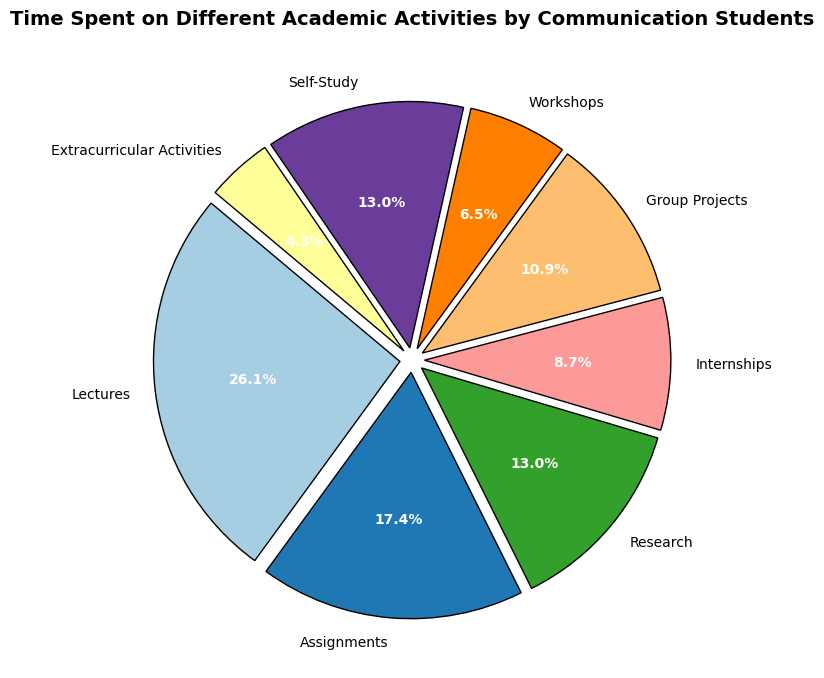What is the total time spent on Research and Self-Study per week? First, identify the hours spent on each activity: Research (6 hours) and Self-Study (6 hours). Add these hours together: 6 + 6 = 12 hours.
Answer: 12 hours Which activity takes up the most time for communication students per week? Look for the activity with the largest portion of the pie chart. Lectures occupy the largest segment with 12 hours.
Answer: Lectures How much more time do students spend on Lectures compared to Internships? Identify the hours spent on each activity: Lectures (12 hours) and Internships (4 hours). Subtract the hours spent on Internships from Lectures: 12 - 4 = 8 hours.
Answer: 8 hours How many more hours do students spend on Assignments than on Workshops? Identify the hours spent on each activity: Assignments (8 hours) and Workshops (3 hours). Subtract the hours spent on Workshops from Assignments: 8 - 3 = 5 hours.
Answer: 5 hours What percentage of the total weekly hours is spent on Extracurricular Activities? Extracurricular Activities take up 2 hours per week. Calculate the total weekly hours by summing all activities: 12 + 8 + 6 + 4 + 5 + 3 + 6 + 2 = 46 hours. Then, find the percentage: (2 / 46) * 100 = ≈ 4.4%.
Answer: ≈ 4.4% How do the hours spent on Group Projects compare to Research? Identify the hours spent on each activity: Group Projects (5 hours) and Research (6 hours). Group Projects have 1 hour less than Research.
Answer: 1 hour less What two activities combined have the same total hours as Lectures? Identify two activities whose combined hours equal those of Lectures (12 hours). Group Projects and Self-Study fit this: Group Projects (5 hours) + Self-Study (6 hours) = 11 hours. Need correction. Research (6 hours) + Self-Study (6 hours) = 12 hours.
Answer: Research and Self-Study If students spend half of their Self-Study hours on Internships instead, how many hours will each activity then have? Initially, Self-Study has 6 hours and Internships have 4 hours. Half of Self-Study (6/2 = 3 hours) will be transferred to Internships. New hours: Self-Study (6 - 3 = 3 hours) and Internships (4 + 3 = 7 hours).
Answer: Self-Study: 3 hours, Internships: 7 hours What is the average number of hours spent on Group Projects, Workshops, and Extracurricular Activities? Identify the hours spent on each activity: Group Projects (5 hours), Workshops (3 hours), and Extracurricular Activities (2 hours). Sum these hours and divide by the number of activities: (5 + 3 + 2) / 3 = 10 / 3 = 3.33 hours.
Answer: 3.33 hours Which activity has the smallest percentage of total weekly hours and what is this percentage? Identify the activity with the smallest segment in the pie chart: Extracurricular Activities with 2 hours. Calculate the percentage: (2 / 46) * 100 = ≈ 4.4%.
Answer: Extracurricular Activities, ≈ 4.4% 